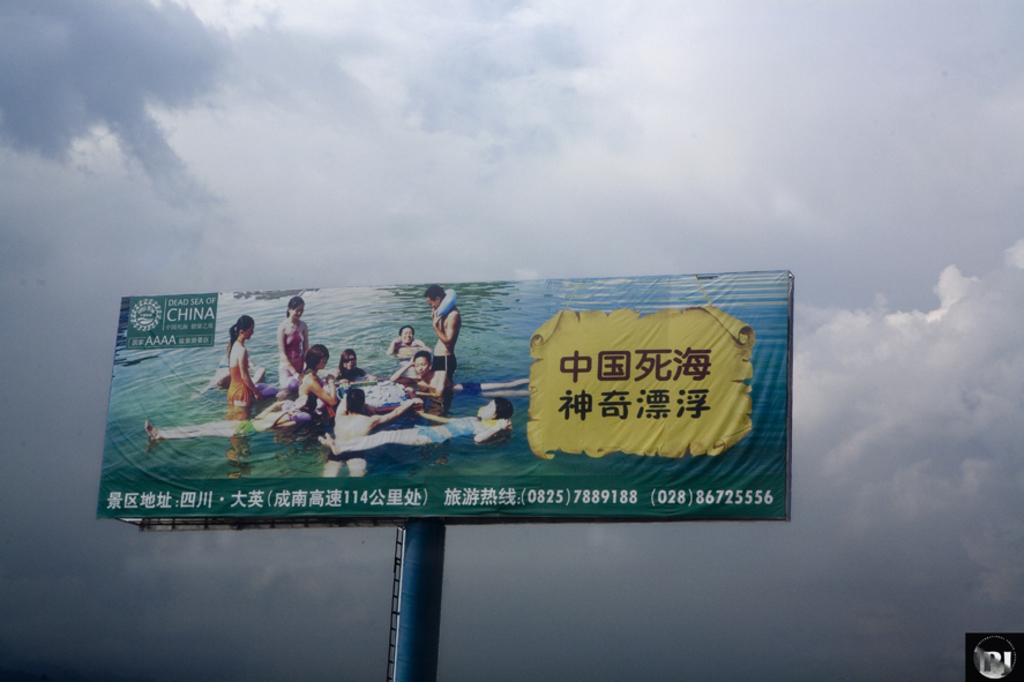Provide a one-sentence caption for the provided image. A billboard from the Dead Sea of China showing  Asian Men and Women in a body of water. 